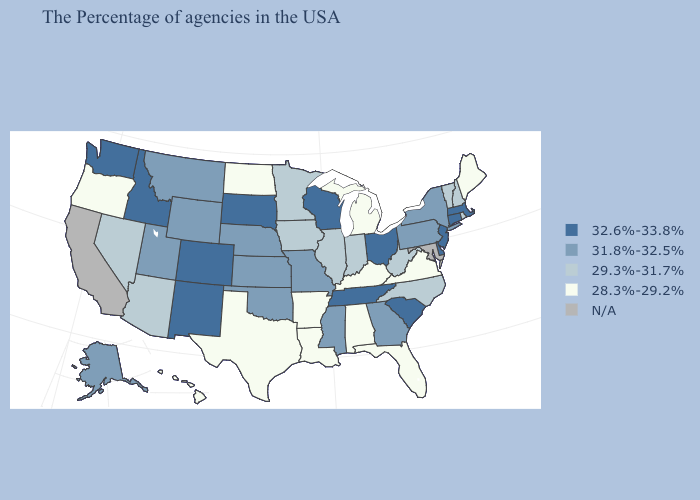Name the states that have a value in the range 29.3%-31.7%?
Concise answer only. Rhode Island, New Hampshire, Vermont, North Carolina, West Virginia, Indiana, Illinois, Minnesota, Iowa, Arizona, Nevada. Name the states that have a value in the range 32.6%-33.8%?
Short answer required. Massachusetts, Connecticut, New Jersey, Delaware, South Carolina, Ohio, Tennessee, Wisconsin, South Dakota, Colorado, New Mexico, Idaho, Washington. What is the lowest value in the USA?
Answer briefly. 28.3%-29.2%. Among the states that border Nevada , does Utah have the lowest value?
Be succinct. No. What is the value of Arkansas?
Keep it brief. 28.3%-29.2%. Is the legend a continuous bar?
Concise answer only. No. What is the value of Tennessee?
Be succinct. 32.6%-33.8%. What is the lowest value in the USA?
Quick response, please. 28.3%-29.2%. What is the lowest value in the USA?
Keep it brief. 28.3%-29.2%. Among the states that border Iowa , which have the lowest value?
Keep it brief. Illinois, Minnesota. What is the highest value in the South ?
Answer briefly. 32.6%-33.8%. Name the states that have a value in the range 28.3%-29.2%?
Quick response, please. Maine, Virginia, Florida, Michigan, Kentucky, Alabama, Louisiana, Arkansas, Texas, North Dakota, Oregon, Hawaii. Does Indiana have the highest value in the MidWest?
Concise answer only. No. Name the states that have a value in the range 32.6%-33.8%?
Keep it brief. Massachusetts, Connecticut, New Jersey, Delaware, South Carolina, Ohio, Tennessee, Wisconsin, South Dakota, Colorado, New Mexico, Idaho, Washington. What is the highest value in states that border Utah?
Write a very short answer. 32.6%-33.8%. 